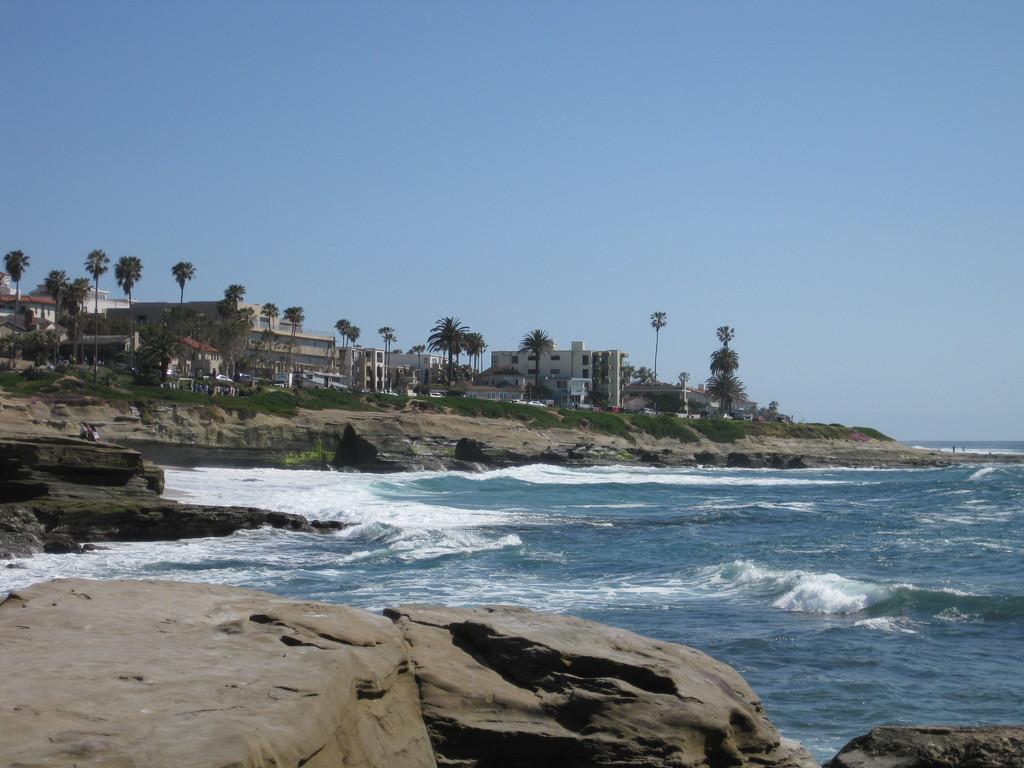Could you give a brief overview of what you see in this image? In this image we can see the sea. There are many trees in the image. There are many rocks in the image. We can see the sky in the image. There are many buildings in the image. There is a grassy land in the image. 